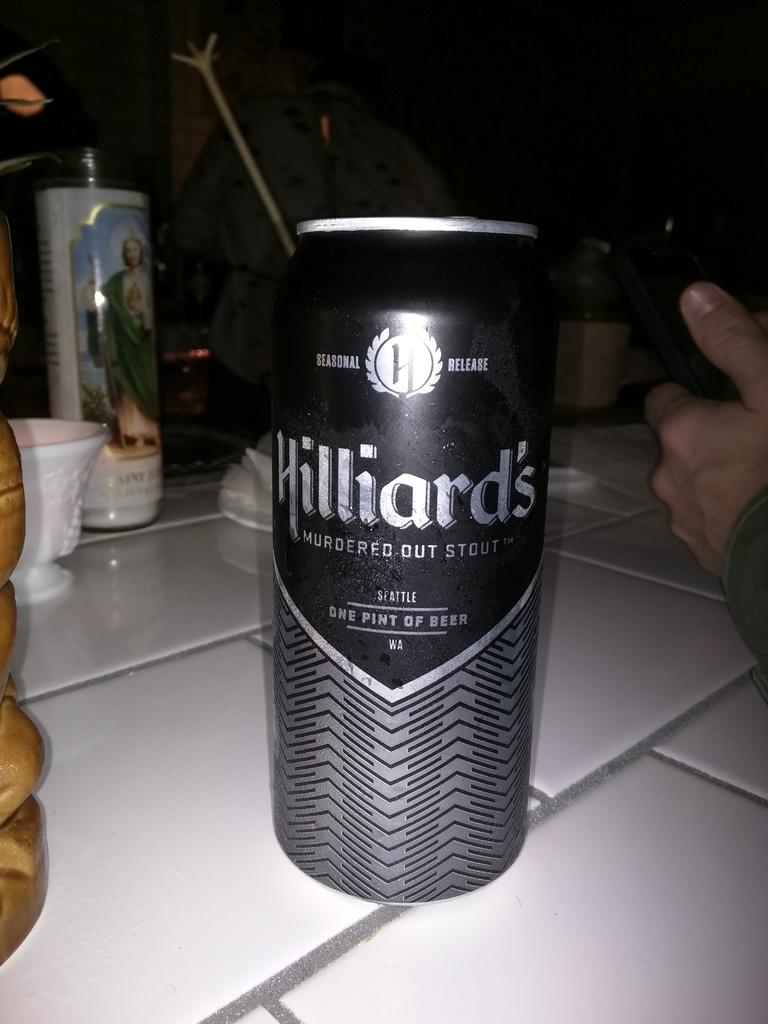<image>
Present a compact description of the photo's key features. Hilliard's is a seasonal release stout from Seattle. 